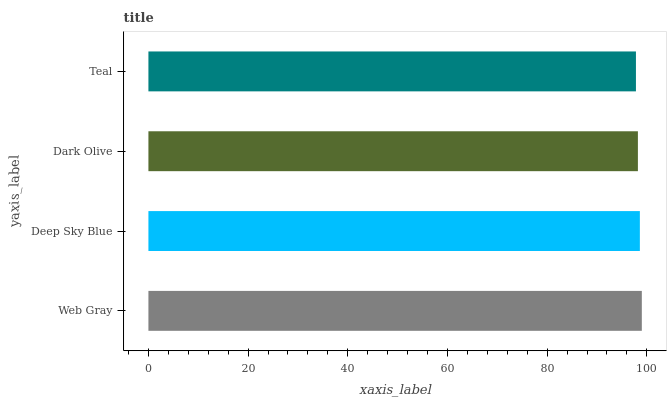Is Teal the minimum?
Answer yes or no. Yes. Is Web Gray the maximum?
Answer yes or no. Yes. Is Deep Sky Blue the minimum?
Answer yes or no. No. Is Deep Sky Blue the maximum?
Answer yes or no. No. Is Web Gray greater than Deep Sky Blue?
Answer yes or no. Yes. Is Deep Sky Blue less than Web Gray?
Answer yes or no. Yes. Is Deep Sky Blue greater than Web Gray?
Answer yes or no. No. Is Web Gray less than Deep Sky Blue?
Answer yes or no. No. Is Deep Sky Blue the high median?
Answer yes or no. Yes. Is Dark Olive the low median?
Answer yes or no. Yes. Is Teal the high median?
Answer yes or no. No. Is Deep Sky Blue the low median?
Answer yes or no. No. 